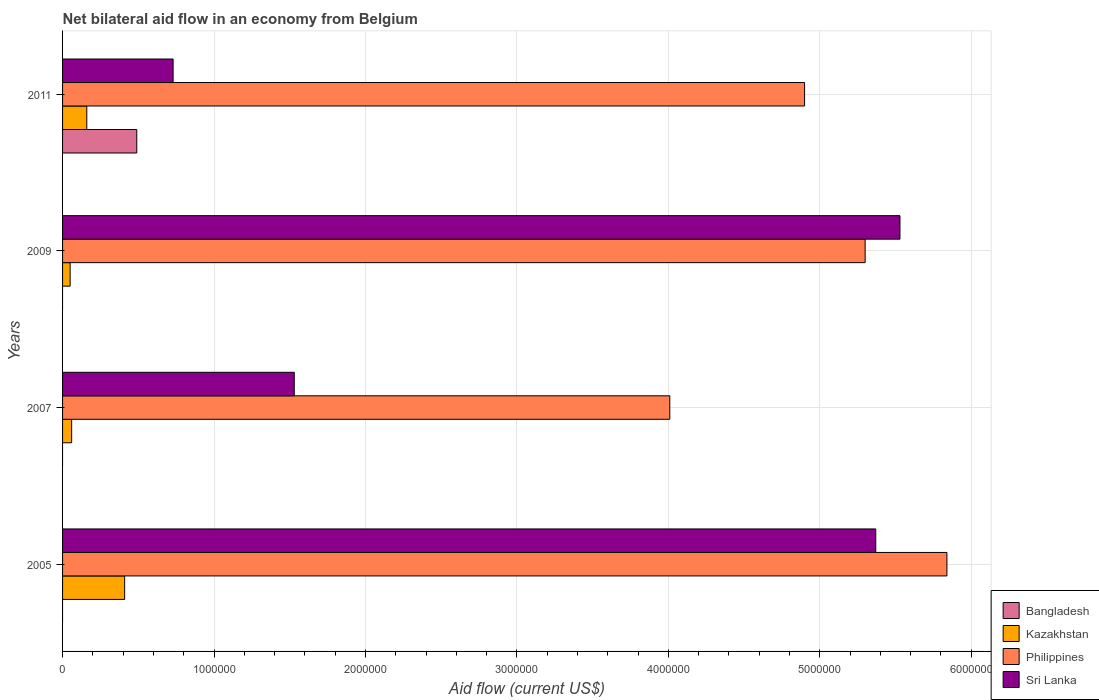How many different coloured bars are there?
Provide a short and direct response. 4. How many groups of bars are there?
Offer a terse response. 4. How many bars are there on the 2nd tick from the top?
Offer a very short reply. 3. How many bars are there on the 1st tick from the bottom?
Offer a terse response. 3. What is the label of the 2nd group of bars from the top?
Provide a succinct answer. 2009. In how many cases, is the number of bars for a given year not equal to the number of legend labels?
Your answer should be very brief. 3. What is the net bilateral aid flow in Sri Lanka in 2005?
Provide a succinct answer. 5.37e+06. Across all years, what is the maximum net bilateral aid flow in Kazakhstan?
Offer a terse response. 4.10e+05. Across all years, what is the minimum net bilateral aid flow in Philippines?
Your response must be concise. 4.01e+06. In which year was the net bilateral aid flow in Sri Lanka maximum?
Your response must be concise. 2009. What is the total net bilateral aid flow in Philippines in the graph?
Offer a very short reply. 2.00e+07. What is the difference between the net bilateral aid flow in Kazakhstan in 2005 and that in 2009?
Keep it short and to the point. 3.60e+05. What is the difference between the net bilateral aid flow in Sri Lanka in 2009 and the net bilateral aid flow in Philippines in 2011?
Keep it short and to the point. 6.30e+05. What is the average net bilateral aid flow in Bangladesh per year?
Your answer should be very brief. 1.22e+05. In the year 2009, what is the difference between the net bilateral aid flow in Kazakhstan and net bilateral aid flow in Sri Lanka?
Offer a terse response. -5.48e+06. What is the ratio of the net bilateral aid flow in Philippines in 2005 to that in 2009?
Make the answer very short. 1.1. Is the net bilateral aid flow in Kazakhstan in 2005 less than that in 2011?
Make the answer very short. No. What is the difference between the highest and the second highest net bilateral aid flow in Philippines?
Your response must be concise. 5.40e+05. What is the difference between the highest and the lowest net bilateral aid flow in Bangladesh?
Provide a succinct answer. 4.90e+05. How many bars are there?
Offer a terse response. 13. Are all the bars in the graph horizontal?
Make the answer very short. Yes. Are the values on the major ticks of X-axis written in scientific E-notation?
Ensure brevity in your answer.  No. Does the graph contain any zero values?
Ensure brevity in your answer.  Yes. Does the graph contain grids?
Ensure brevity in your answer.  Yes. What is the title of the graph?
Make the answer very short. Net bilateral aid flow in an economy from Belgium. Does "Guyana" appear as one of the legend labels in the graph?
Provide a succinct answer. No. What is the Aid flow (current US$) in Philippines in 2005?
Provide a short and direct response. 5.84e+06. What is the Aid flow (current US$) of Sri Lanka in 2005?
Your answer should be compact. 5.37e+06. What is the Aid flow (current US$) of Bangladesh in 2007?
Ensure brevity in your answer.  0. What is the Aid flow (current US$) in Philippines in 2007?
Offer a terse response. 4.01e+06. What is the Aid flow (current US$) in Sri Lanka in 2007?
Provide a succinct answer. 1.53e+06. What is the Aid flow (current US$) in Bangladesh in 2009?
Keep it short and to the point. 0. What is the Aid flow (current US$) of Kazakhstan in 2009?
Your answer should be very brief. 5.00e+04. What is the Aid flow (current US$) of Philippines in 2009?
Offer a very short reply. 5.30e+06. What is the Aid flow (current US$) in Sri Lanka in 2009?
Your answer should be very brief. 5.53e+06. What is the Aid flow (current US$) of Bangladesh in 2011?
Provide a short and direct response. 4.90e+05. What is the Aid flow (current US$) in Philippines in 2011?
Your answer should be compact. 4.90e+06. What is the Aid flow (current US$) of Sri Lanka in 2011?
Your response must be concise. 7.30e+05. Across all years, what is the maximum Aid flow (current US$) in Bangladesh?
Ensure brevity in your answer.  4.90e+05. Across all years, what is the maximum Aid flow (current US$) in Philippines?
Your response must be concise. 5.84e+06. Across all years, what is the maximum Aid flow (current US$) in Sri Lanka?
Give a very brief answer. 5.53e+06. Across all years, what is the minimum Aid flow (current US$) in Kazakhstan?
Offer a terse response. 5.00e+04. Across all years, what is the minimum Aid flow (current US$) of Philippines?
Offer a very short reply. 4.01e+06. Across all years, what is the minimum Aid flow (current US$) in Sri Lanka?
Give a very brief answer. 7.30e+05. What is the total Aid flow (current US$) of Kazakhstan in the graph?
Offer a terse response. 6.80e+05. What is the total Aid flow (current US$) of Philippines in the graph?
Make the answer very short. 2.00e+07. What is the total Aid flow (current US$) in Sri Lanka in the graph?
Your answer should be very brief. 1.32e+07. What is the difference between the Aid flow (current US$) of Kazakhstan in 2005 and that in 2007?
Offer a terse response. 3.50e+05. What is the difference between the Aid flow (current US$) in Philippines in 2005 and that in 2007?
Your response must be concise. 1.83e+06. What is the difference between the Aid flow (current US$) of Sri Lanka in 2005 and that in 2007?
Ensure brevity in your answer.  3.84e+06. What is the difference between the Aid flow (current US$) of Philippines in 2005 and that in 2009?
Provide a short and direct response. 5.40e+05. What is the difference between the Aid flow (current US$) in Kazakhstan in 2005 and that in 2011?
Provide a short and direct response. 2.50e+05. What is the difference between the Aid flow (current US$) of Philippines in 2005 and that in 2011?
Your answer should be very brief. 9.40e+05. What is the difference between the Aid flow (current US$) in Sri Lanka in 2005 and that in 2011?
Ensure brevity in your answer.  4.64e+06. What is the difference between the Aid flow (current US$) of Philippines in 2007 and that in 2009?
Provide a succinct answer. -1.29e+06. What is the difference between the Aid flow (current US$) of Kazakhstan in 2007 and that in 2011?
Give a very brief answer. -1.00e+05. What is the difference between the Aid flow (current US$) of Philippines in 2007 and that in 2011?
Your response must be concise. -8.90e+05. What is the difference between the Aid flow (current US$) in Sri Lanka in 2007 and that in 2011?
Ensure brevity in your answer.  8.00e+05. What is the difference between the Aid flow (current US$) in Philippines in 2009 and that in 2011?
Your answer should be compact. 4.00e+05. What is the difference between the Aid flow (current US$) in Sri Lanka in 2009 and that in 2011?
Your response must be concise. 4.80e+06. What is the difference between the Aid flow (current US$) of Kazakhstan in 2005 and the Aid flow (current US$) of Philippines in 2007?
Provide a succinct answer. -3.60e+06. What is the difference between the Aid flow (current US$) of Kazakhstan in 2005 and the Aid flow (current US$) of Sri Lanka in 2007?
Provide a succinct answer. -1.12e+06. What is the difference between the Aid flow (current US$) of Philippines in 2005 and the Aid flow (current US$) of Sri Lanka in 2007?
Provide a short and direct response. 4.31e+06. What is the difference between the Aid flow (current US$) in Kazakhstan in 2005 and the Aid flow (current US$) in Philippines in 2009?
Offer a terse response. -4.89e+06. What is the difference between the Aid flow (current US$) in Kazakhstan in 2005 and the Aid flow (current US$) in Sri Lanka in 2009?
Your answer should be compact. -5.12e+06. What is the difference between the Aid flow (current US$) of Philippines in 2005 and the Aid flow (current US$) of Sri Lanka in 2009?
Your response must be concise. 3.10e+05. What is the difference between the Aid flow (current US$) of Kazakhstan in 2005 and the Aid flow (current US$) of Philippines in 2011?
Provide a short and direct response. -4.49e+06. What is the difference between the Aid flow (current US$) in Kazakhstan in 2005 and the Aid flow (current US$) in Sri Lanka in 2011?
Your answer should be compact. -3.20e+05. What is the difference between the Aid flow (current US$) in Philippines in 2005 and the Aid flow (current US$) in Sri Lanka in 2011?
Make the answer very short. 5.11e+06. What is the difference between the Aid flow (current US$) of Kazakhstan in 2007 and the Aid flow (current US$) of Philippines in 2009?
Offer a terse response. -5.24e+06. What is the difference between the Aid flow (current US$) of Kazakhstan in 2007 and the Aid flow (current US$) of Sri Lanka in 2009?
Give a very brief answer. -5.47e+06. What is the difference between the Aid flow (current US$) in Philippines in 2007 and the Aid flow (current US$) in Sri Lanka in 2009?
Provide a short and direct response. -1.52e+06. What is the difference between the Aid flow (current US$) of Kazakhstan in 2007 and the Aid flow (current US$) of Philippines in 2011?
Ensure brevity in your answer.  -4.84e+06. What is the difference between the Aid flow (current US$) in Kazakhstan in 2007 and the Aid flow (current US$) in Sri Lanka in 2011?
Keep it short and to the point. -6.70e+05. What is the difference between the Aid flow (current US$) in Philippines in 2007 and the Aid flow (current US$) in Sri Lanka in 2011?
Offer a very short reply. 3.28e+06. What is the difference between the Aid flow (current US$) of Kazakhstan in 2009 and the Aid flow (current US$) of Philippines in 2011?
Your answer should be compact. -4.85e+06. What is the difference between the Aid flow (current US$) in Kazakhstan in 2009 and the Aid flow (current US$) in Sri Lanka in 2011?
Your answer should be compact. -6.80e+05. What is the difference between the Aid flow (current US$) of Philippines in 2009 and the Aid flow (current US$) of Sri Lanka in 2011?
Your answer should be compact. 4.57e+06. What is the average Aid flow (current US$) in Bangladesh per year?
Offer a very short reply. 1.22e+05. What is the average Aid flow (current US$) in Philippines per year?
Provide a succinct answer. 5.01e+06. What is the average Aid flow (current US$) in Sri Lanka per year?
Offer a very short reply. 3.29e+06. In the year 2005, what is the difference between the Aid flow (current US$) of Kazakhstan and Aid flow (current US$) of Philippines?
Your answer should be very brief. -5.43e+06. In the year 2005, what is the difference between the Aid flow (current US$) in Kazakhstan and Aid flow (current US$) in Sri Lanka?
Your answer should be very brief. -4.96e+06. In the year 2007, what is the difference between the Aid flow (current US$) of Kazakhstan and Aid flow (current US$) of Philippines?
Your answer should be very brief. -3.95e+06. In the year 2007, what is the difference between the Aid flow (current US$) in Kazakhstan and Aid flow (current US$) in Sri Lanka?
Make the answer very short. -1.47e+06. In the year 2007, what is the difference between the Aid flow (current US$) of Philippines and Aid flow (current US$) of Sri Lanka?
Offer a terse response. 2.48e+06. In the year 2009, what is the difference between the Aid flow (current US$) of Kazakhstan and Aid flow (current US$) of Philippines?
Your response must be concise. -5.25e+06. In the year 2009, what is the difference between the Aid flow (current US$) of Kazakhstan and Aid flow (current US$) of Sri Lanka?
Offer a very short reply. -5.48e+06. In the year 2011, what is the difference between the Aid flow (current US$) of Bangladesh and Aid flow (current US$) of Kazakhstan?
Ensure brevity in your answer.  3.30e+05. In the year 2011, what is the difference between the Aid flow (current US$) in Bangladesh and Aid flow (current US$) in Philippines?
Offer a very short reply. -4.41e+06. In the year 2011, what is the difference between the Aid flow (current US$) in Kazakhstan and Aid flow (current US$) in Philippines?
Ensure brevity in your answer.  -4.74e+06. In the year 2011, what is the difference between the Aid flow (current US$) of Kazakhstan and Aid flow (current US$) of Sri Lanka?
Give a very brief answer. -5.70e+05. In the year 2011, what is the difference between the Aid flow (current US$) of Philippines and Aid flow (current US$) of Sri Lanka?
Your answer should be very brief. 4.17e+06. What is the ratio of the Aid flow (current US$) in Kazakhstan in 2005 to that in 2007?
Your answer should be compact. 6.83. What is the ratio of the Aid flow (current US$) in Philippines in 2005 to that in 2007?
Keep it short and to the point. 1.46. What is the ratio of the Aid flow (current US$) of Sri Lanka in 2005 to that in 2007?
Provide a short and direct response. 3.51. What is the ratio of the Aid flow (current US$) in Kazakhstan in 2005 to that in 2009?
Ensure brevity in your answer.  8.2. What is the ratio of the Aid flow (current US$) of Philippines in 2005 to that in 2009?
Offer a very short reply. 1.1. What is the ratio of the Aid flow (current US$) of Sri Lanka in 2005 to that in 2009?
Make the answer very short. 0.97. What is the ratio of the Aid flow (current US$) of Kazakhstan in 2005 to that in 2011?
Your response must be concise. 2.56. What is the ratio of the Aid flow (current US$) of Philippines in 2005 to that in 2011?
Ensure brevity in your answer.  1.19. What is the ratio of the Aid flow (current US$) of Sri Lanka in 2005 to that in 2011?
Your response must be concise. 7.36. What is the ratio of the Aid flow (current US$) in Philippines in 2007 to that in 2009?
Ensure brevity in your answer.  0.76. What is the ratio of the Aid flow (current US$) in Sri Lanka in 2007 to that in 2009?
Ensure brevity in your answer.  0.28. What is the ratio of the Aid flow (current US$) of Kazakhstan in 2007 to that in 2011?
Offer a terse response. 0.38. What is the ratio of the Aid flow (current US$) in Philippines in 2007 to that in 2011?
Offer a terse response. 0.82. What is the ratio of the Aid flow (current US$) in Sri Lanka in 2007 to that in 2011?
Offer a very short reply. 2.1. What is the ratio of the Aid flow (current US$) in Kazakhstan in 2009 to that in 2011?
Provide a succinct answer. 0.31. What is the ratio of the Aid flow (current US$) of Philippines in 2009 to that in 2011?
Provide a short and direct response. 1.08. What is the ratio of the Aid flow (current US$) in Sri Lanka in 2009 to that in 2011?
Ensure brevity in your answer.  7.58. What is the difference between the highest and the second highest Aid flow (current US$) in Kazakhstan?
Provide a short and direct response. 2.50e+05. What is the difference between the highest and the second highest Aid flow (current US$) in Philippines?
Make the answer very short. 5.40e+05. What is the difference between the highest and the lowest Aid flow (current US$) in Kazakhstan?
Offer a terse response. 3.60e+05. What is the difference between the highest and the lowest Aid flow (current US$) in Philippines?
Provide a short and direct response. 1.83e+06. What is the difference between the highest and the lowest Aid flow (current US$) of Sri Lanka?
Ensure brevity in your answer.  4.80e+06. 